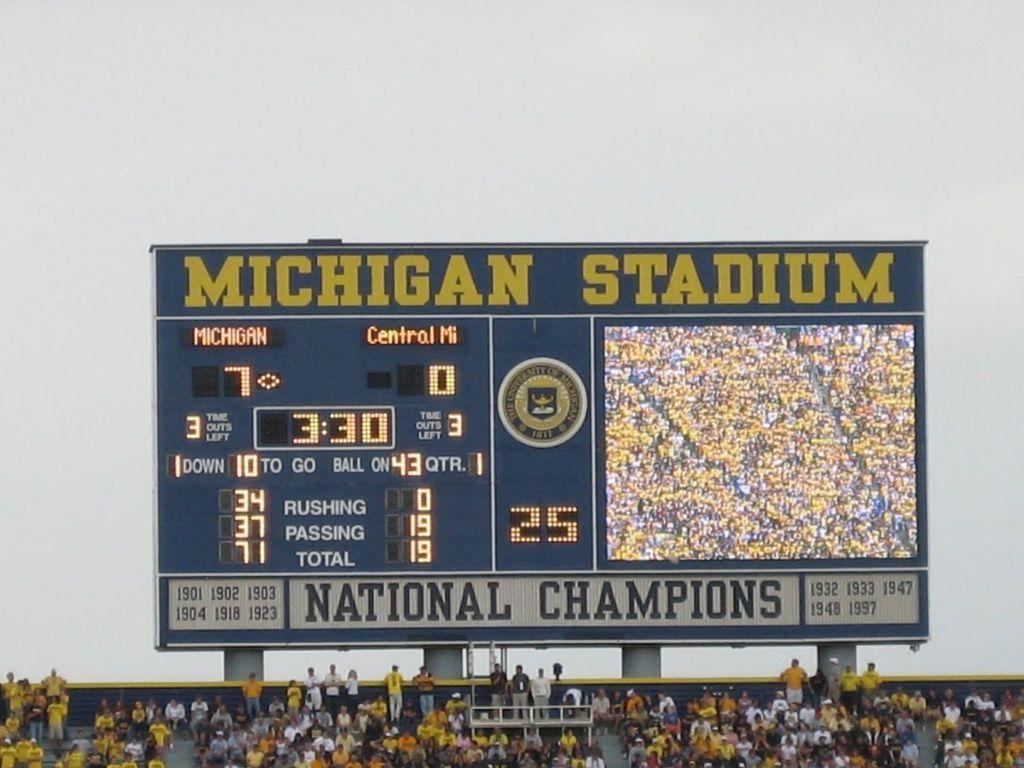<image>
Share a concise interpretation of the image provided. Fans are gathered in the stands at Michigan Stadium where Michigan State is playing Central Michigan University. 